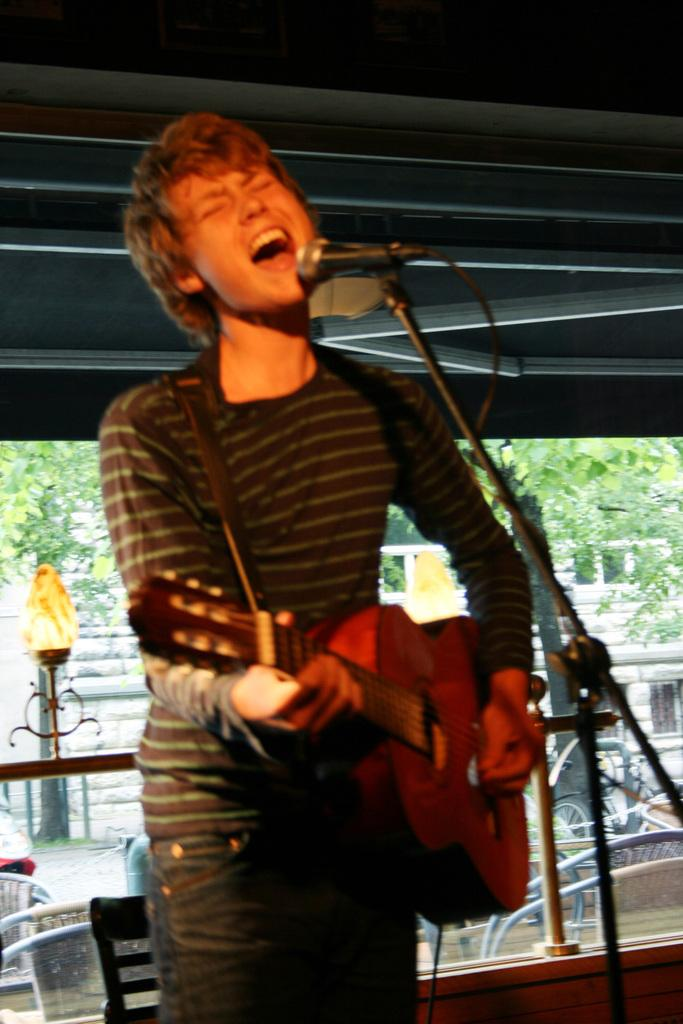Who is present in the image? There is a man in the image. What is the man doing in the image? The man is standing in the image. What object is the man holding in the image? The man is holding a guitar in his hand. What type of clocks can be seen in the image? There are no clocks present in the image. What is the man protesting about in the image? There is no protest or any indication of a protest in the image. 